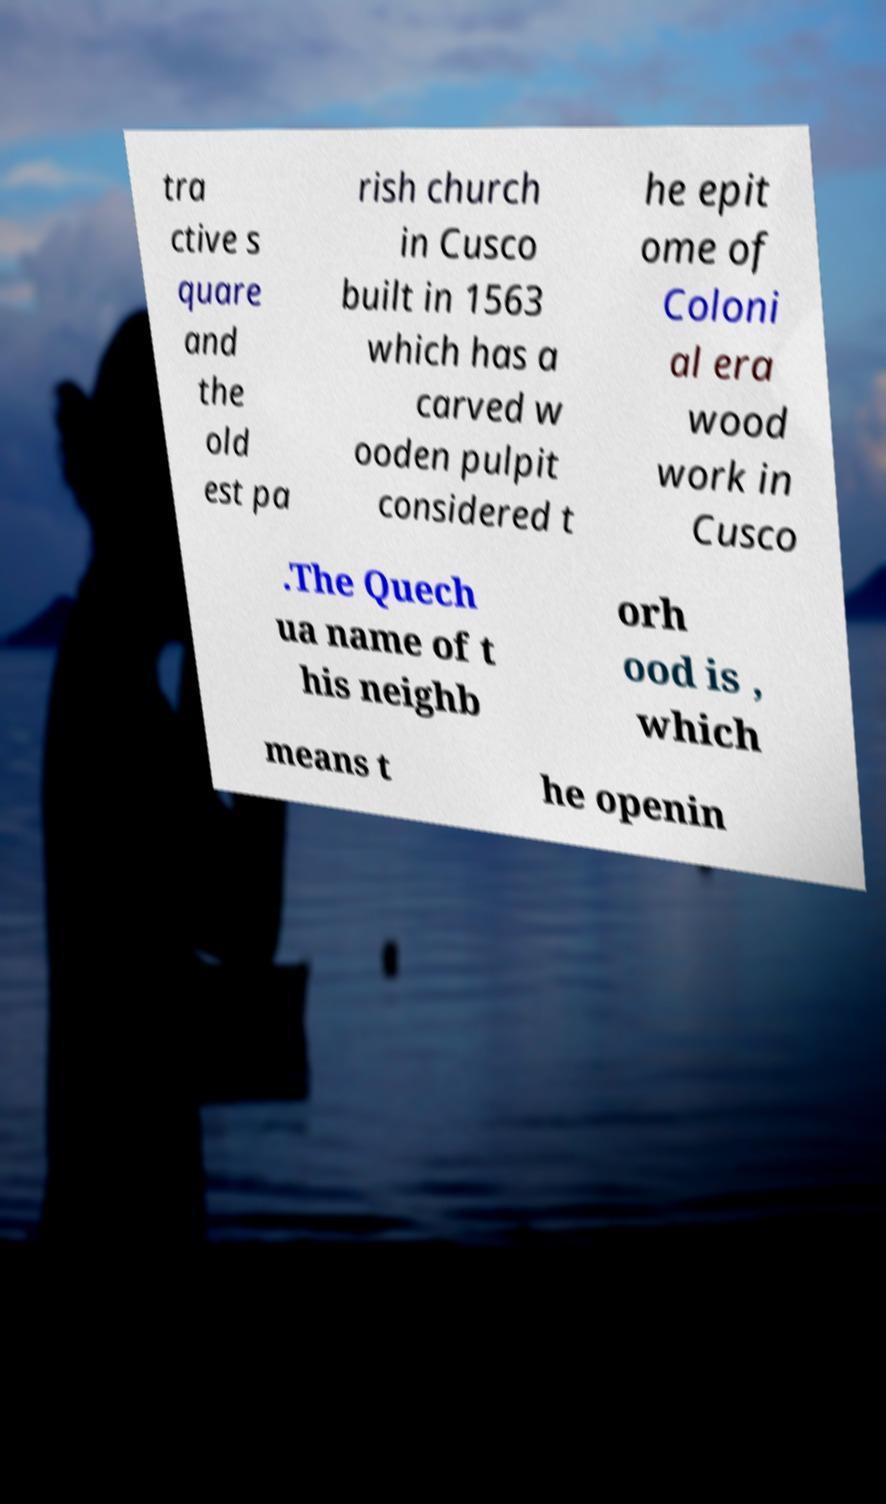I need the written content from this picture converted into text. Can you do that? tra ctive s quare and the old est pa rish church in Cusco built in 1563 which has a carved w ooden pulpit considered t he epit ome of Coloni al era wood work in Cusco .The Quech ua name of t his neighb orh ood is , which means t he openin 